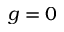Convert formula to latex. <formula><loc_0><loc_0><loc_500><loc_500>g = 0</formula> 